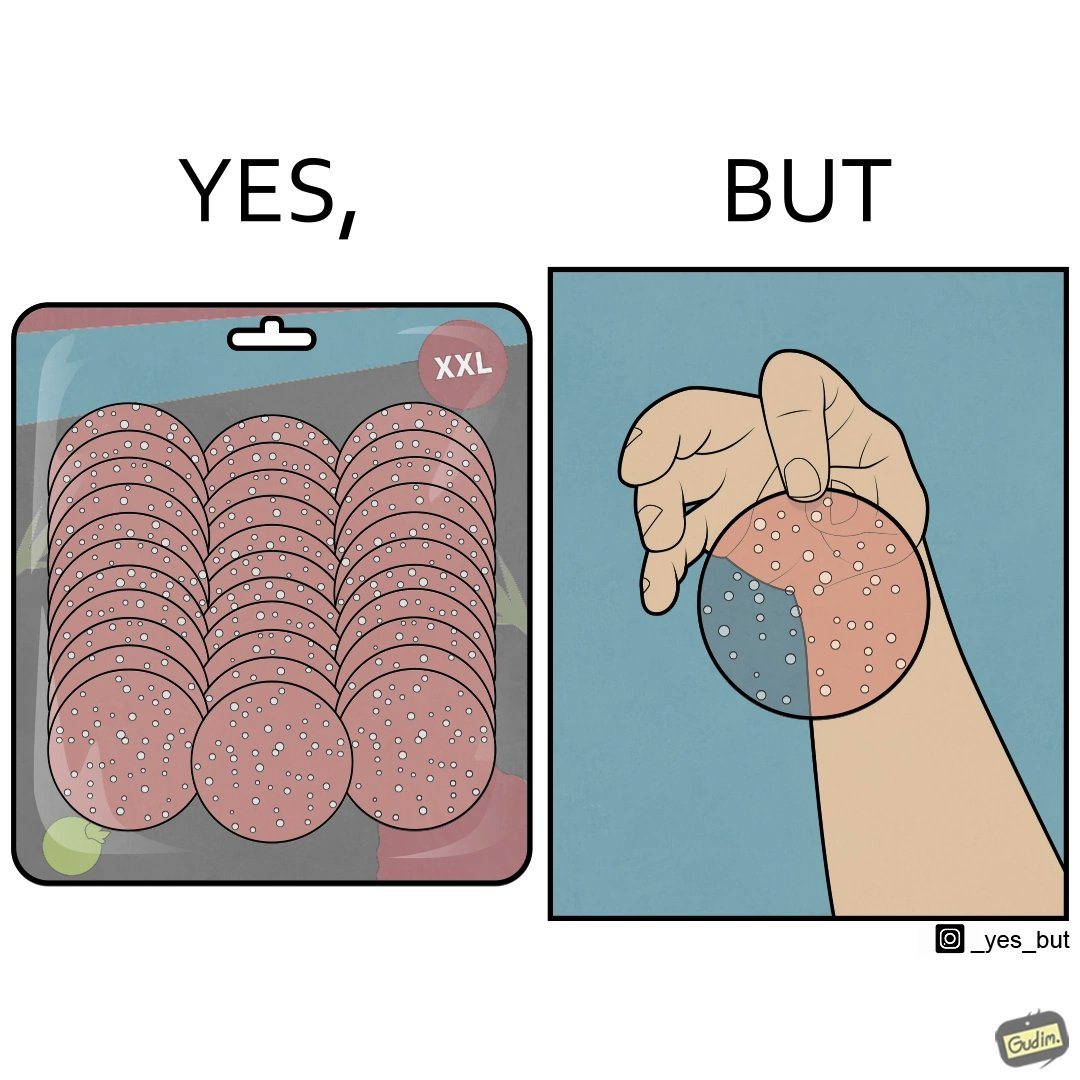Explain why this image is satirical. The irony in this image describes shrinkflation, which is when stores start selling big bags of products with less product in them. 